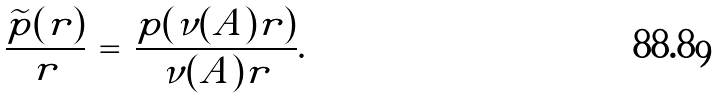<formula> <loc_0><loc_0><loc_500><loc_500>\frac { \widetilde { p } ( r ) } { r } \, = \, \frac { { p } ( \nu ( A ) r ) } { \nu ( A ) r } .</formula> 